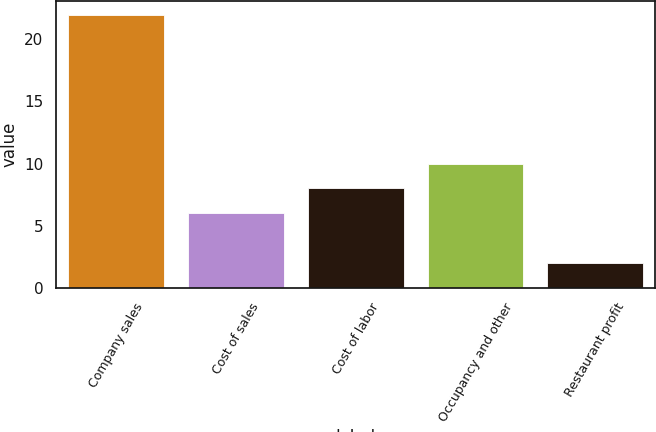Convert chart to OTSL. <chart><loc_0><loc_0><loc_500><loc_500><bar_chart><fcel>Company sales<fcel>Cost of sales<fcel>Cost of labor<fcel>Occupancy and other<fcel>Restaurant profit<nl><fcel>22<fcel>6<fcel>8<fcel>10<fcel>2<nl></chart> 